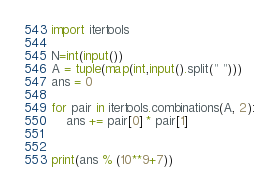Convert code to text. <code><loc_0><loc_0><loc_500><loc_500><_Python_>import itertools

N=int(input())
A = tuple(map(int,input().split(" ")))
ans = 0

for pair in itertools.combinations(A, 2):
    ans += pair[0] * pair[1]


print(ans % (10**9+7))</code> 